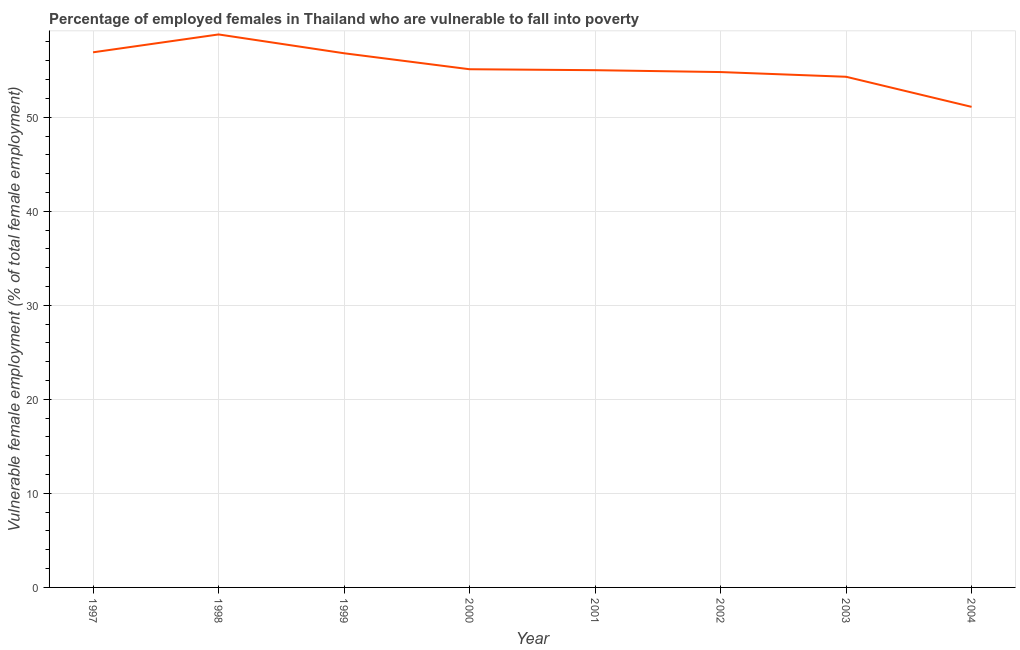What is the percentage of employed females who are vulnerable to fall into poverty in 2004?
Provide a succinct answer. 51.1. Across all years, what is the maximum percentage of employed females who are vulnerable to fall into poverty?
Give a very brief answer. 58.8. Across all years, what is the minimum percentage of employed females who are vulnerable to fall into poverty?
Offer a terse response. 51.1. What is the sum of the percentage of employed females who are vulnerable to fall into poverty?
Offer a terse response. 442.8. What is the difference between the percentage of employed females who are vulnerable to fall into poverty in 1998 and 2001?
Your answer should be very brief. 3.8. What is the average percentage of employed females who are vulnerable to fall into poverty per year?
Give a very brief answer. 55.35. What is the median percentage of employed females who are vulnerable to fall into poverty?
Keep it short and to the point. 55.05. In how many years, is the percentage of employed females who are vulnerable to fall into poverty greater than 26 %?
Give a very brief answer. 8. Do a majority of the years between 1999 and 2003 (inclusive) have percentage of employed females who are vulnerable to fall into poverty greater than 20 %?
Provide a short and direct response. Yes. What is the ratio of the percentage of employed females who are vulnerable to fall into poverty in 2000 to that in 2004?
Offer a terse response. 1.08. Is the percentage of employed females who are vulnerable to fall into poverty in 1999 less than that in 2003?
Provide a short and direct response. No. Is the difference between the percentage of employed females who are vulnerable to fall into poverty in 1998 and 2002 greater than the difference between any two years?
Keep it short and to the point. No. What is the difference between the highest and the second highest percentage of employed females who are vulnerable to fall into poverty?
Provide a succinct answer. 1.9. Is the sum of the percentage of employed females who are vulnerable to fall into poverty in 1999 and 2000 greater than the maximum percentage of employed females who are vulnerable to fall into poverty across all years?
Your response must be concise. Yes. What is the difference between the highest and the lowest percentage of employed females who are vulnerable to fall into poverty?
Provide a short and direct response. 7.7. In how many years, is the percentage of employed females who are vulnerable to fall into poverty greater than the average percentage of employed females who are vulnerable to fall into poverty taken over all years?
Offer a terse response. 3. Does the percentage of employed females who are vulnerable to fall into poverty monotonically increase over the years?
Provide a succinct answer. No. How many years are there in the graph?
Give a very brief answer. 8. Are the values on the major ticks of Y-axis written in scientific E-notation?
Your response must be concise. No. Does the graph contain any zero values?
Give a very brief answer. No. Does the graph contain grids?
Provide a short and direct response. Yes. What is the title of the graph?
Keep it short and to the point. Percentage of employed females in Thailand who are vulnerable to fall into poverty. What is the label or title of the Y-axis?
Give a very brief answer. Vulnerable female employment (% of total female employment). What is the Vulnerable female employment (% of total female employment) in 1997?
Make the answer very short. 56.9. What is the Vulnerable female employment (% of total female employment) of 1998?
Give a very brief answer. 58.8. What is the Vulnerable female employment (% of total female employment) of 1999?
Offer a terse response. 56.8. What is the Vulnerable female employment (% of total female employment) in 2000?
Give a very brief answer. 55.1. What is the Vulnerable female employment (% of total female employment) in 2002?
Offer a terse response. 54.8. What is the Vulnerable female employment (% of total female employment) of 2003?
Offer a very short reply. 54.3. What is the Vulnerable female employment (% of total female employment) in 2004?
Offer a very short reply. 51.1. What is the difference between the Vulnerable female employment (% of total female employment) in 1997 and 1999?
Give a very brief answer. 0.1. What is the difference between the Vulnerable female employment (% of total female employment) in 1997 and 2004?
Provide a succinct answer. 5.8. What is the difference between the Vulnerable female employment (% of total female employment) in 1998 and 2001?
Your answer should be compact. 3.8. What is the difference between the Vulnerable female employment (% of total female employment) in 1998 and 2002?
Ensure brevity in your answer.  4. What is the difference between the Vulnerable female employment (% of total female employment) in 1998 and 2003?
Make the answer very short. 4.5. What is the difference between the Vulnerable female employment (% of total female employment) in 1999 and 2002?
Make the answer very short. 2. What is the difference between the Vulnerable female employment (% of total female employment) in 1999 and 2004?
Ensure brevity in your answer.  5.7. What is the difference between the Vulnerable female employment (% of total female employment) in 2000 and 2003?
Your response must be concise. 0.8. What is the difference between the Vulnerable female employment (% of total female employment) in 2001 and 2003?
Provide a short and direct response. 0.7. What is the difference between the Vulnerable female employment (% of total female employment) in 2002 and 2004?
Provide a short and direct response. 3.7. What is the ratio of the Vulnerable female employment (% of total female employment) in 1997 to that in 1998?
Offer a very short reply. 0.97. What is the ratio of the Vulnerable female employment (% of total female employment) in 1997 to that in 1999?
Offer a very short reply. 1. What is the ratio of the Vulnerable female employment (% of total female employment) in 1997 to that in 2000?
Your response must be concise. 1.03. What is the ratio of the Vulnerable female employment (% of total female employment) in 1997 to that in 2001?
Offer a very short reply. 1.03. What is the ratio of the Vulnerable female employment (% of total female employment) in 1997 to that in 2002?
Offer a terse response. 1.04. What is the ratio of the Vulnerable female employment (% of total female employment) in 1997 to that in 2003?
Offer a very short reply. 1.05. What is the ratio of the Vulnerable female employment (% of total female employment) in 1997 to that in 2004?
Keep it short and to the point. 1.11. What is the ratio of the Vulnerable female employment (% of total female employment) in 1998 to that in 1999?
Your response must be concise. 1.03. What is the ratio of the Vulnerable female employment (% of total female employment) in 1998 to that in 2000?
Your response must be concise. 1.07. What is the ratio of the Vulnerable female employment (% of total female employment) in 1998 to that in 2001?
Give a very brief answer. 1.07. What is the ratio of the Vulnerable female employment (% of total female employment) in 1998 to that in 2002?
Offer a terse response. 1.07. What is the ratio of the Vulnerable female employment (% of total female employment) in 1998 to that in 2003?
Your response must be concise. 1.08. What is the ratio of the Vulnerable female employment (% of total female employment) in 1998 to that in 2004?
Make the answer very short. 1.15. What is the ratio of the Vulnerable female employment (% of total female employment) in 1999 to that in 2000?
Provide a succinct answer. 1.03. What is the ratio of the Vulnerable female employment (% of total female employment) in 1999 to that in 2001?
Make the answer very short. 1.03. What is the ratio of the Vulnerable female employment (% of total female employment) in 1999 to that in 2002?
Make the answer very short. 1.04. What is the ratio of the Vulnerable female employment (% of total female employment) in 1999 to that in 2003?
Give a very brief answer. 1.05. What is the ratio of the Vulnerable female employment (% of total female employment) in 1999 to that in 2004?
Make the answer very short. 1.11. What is the ratio of the Vulnerable female employment (% of total female employment) in 2000 to that in 2001?
Offer a terse response. 1. What is the ratio of the Vulnerable female employment (% of total female employment) in 2000 to that in 2002?
Provide a succinct answer. 1. What is the ratio of the Vulnerable female employment (% of total female employment) in 2000 to that in 2004?
Keep it short and to the point. 1.08. What is the ratio of the Vulnerable female employment (% of total female employment) in 2001 to that in 2002?
Offer a very short reply. 1. What is the ratio of the Vulnerable female employment (% of total female employment) in 2001 to that in 2003?
Give a very brief answer. 1.01. What is the ratio of the Vulnerable female employment (% of total female employment) in 2001 to that in 2004?
Your answer should be very brief. 1.08. What is the ratio of the Vulnerable female employment (% of total female employment) in 2002 to that in 2004?
Your answer should be very brief. 1.07. What is the ratio of the Vulnerable female employment (% of total female employment) in 2003 to that in 2004?
Your response must be concise. 1.06. 